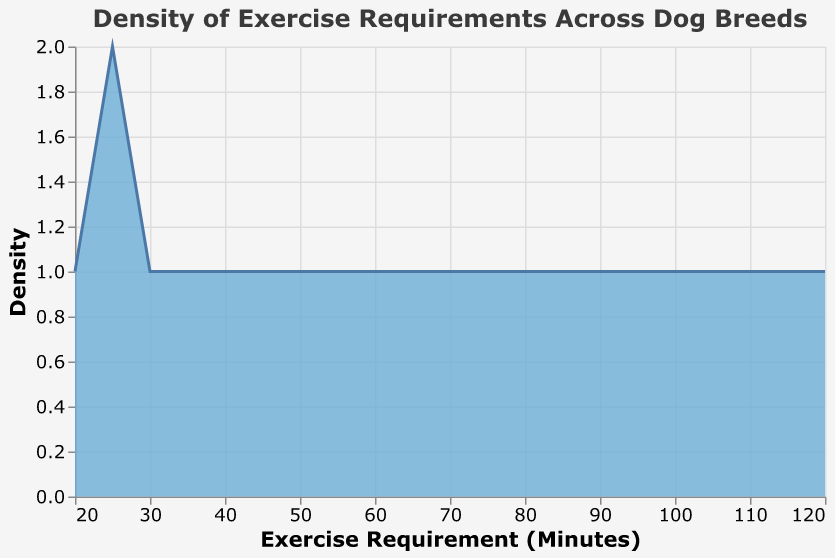What is the title of the figure? The title is prominently displayed at the top of the figure. It summarizes the main topic of the visualization.
Answer: Density of Exercise Requirements Across Dog Breeds What does the x-axis represent? The x-axis represents the variable being measured in this density plot.
Answer: Exercise Requirement (Minutes) How many data points are there in the figure? The data points are represented by the values provided in the JSON data and visualized in the density plot. There are 15 dog breeds, each representing one data point.
Answer: 15 Which breed has the highest exercise requirement? By examining the extreme right of the x-axis, we can determine the breed with the highest exercise requirement.
Answer: Border Collie What is the most common range of exercise requirements based on the plot density? The density plot's peak indicates the most prevalent range of exercise requirements among the breeds. The highest density region appears in the interval around 60 to 90 minutes.
Answer: 60 to 90 minutes How many breeds have exercise requirements less than 30 minutes? Count the number of data points on the left side of the plot before 30 minutes on the x-axis.
Answer: 3 How does the density change between exercise requirements of 60 and 80 minutes? Evaluate the density curve between the x-axis values of 60 and 80 minutes. The density increases slightly as we move from 60 to 80 minutes and then starts to drop off as we proceed further.
Answer: It increases slightly and then decreases Which breed has the lowest exercise requirement? Identify the leftmost point on the x-axis to find the breed with the minimum exercise requirement.
Answer: Chihuahua What is the range of exercise requirements represented in this plot? The range can be determined by finding the minimum and maximum values on the x-axis.
Answer: 20 to 120 minutes How many breeds have an exercise requirement between 50 and 100 minutes? Count the number of data points in the interval from 50 to 100 minutes on the x-axis.
Answer: 8 